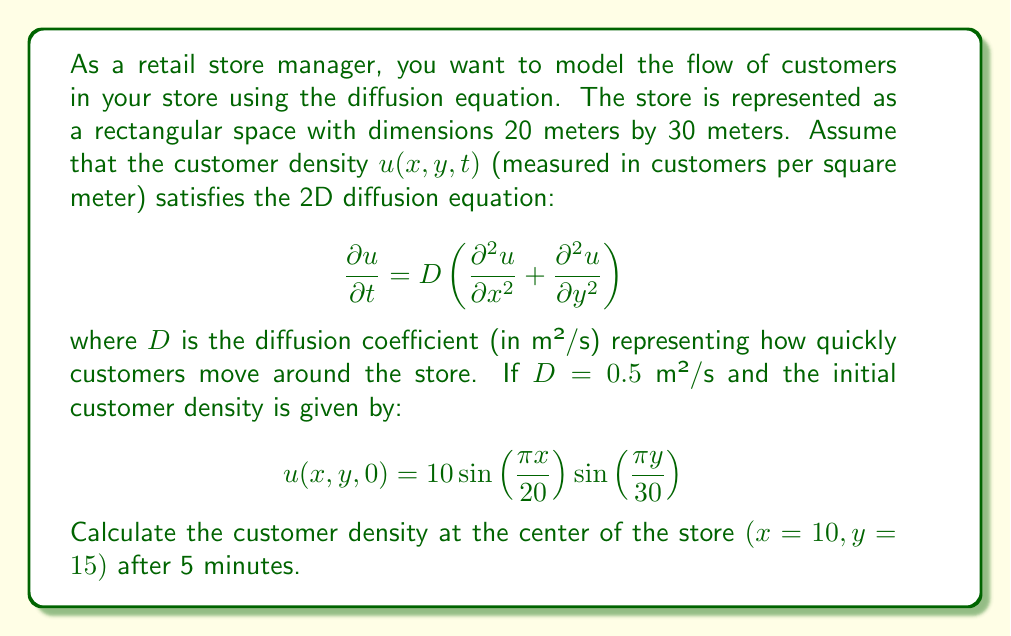Can you answer this question? To solve this problem, we'll follow these steps:

1) First, we need to recognize that the given initial condition satisfies the boundary conditions (zero density at the edges of the store) and has the form of a solution to the 2D diffusion equation.

2) The general solution to the 2D diffusion equation with these boundary conditions is:

   $$u(x,y,t) = A \sin\left(\frac{\pi x}{L_x}\right) \sin\left(\frac{\pi y}{L_y}\right) e^{-\lambda t}$$

   where $L_x = 20$ m and $L_y = 30$ m are the store dimensions.

3) Comparing this to our initial condition, we see that $A = 10$.

4) The decay constant $\lambda$ is given by:

   $$\lambda = D\pi^2 \left(\frac{1}{L_x^2} + \frac{1}{L_y^2}\right)$$

5) Substituting the values:

   $$\lambda = 0.5 \cdot \pi^2 \left(\frac{1}{20^2} + \frac{1}{30^2}\right) = 0.5 \cdot \pi^2 \cdot \frac{13}{3600} \approx 0.0178 \text{ s}^{-1}$$

6) Now we can write the full solution:

   $$u(x,y,t) = 10 \sin\left(\frac{\pi x}{20}\right) \sin\left(\frac{\pi y}{30}\right) e^{-0.0178t}$$

7) To find the density at the center after 5 minutes, we substitute $x=10$, $y=15$, and $t = 5 \cdot 60 = 300$ seconds:

   $$u(10,15,300) = 10 \sin\left(\frac{\pi \cdot 10}{20}\right) \sin\left(\frac{\pi \cdot 15}{30}\right) e^{-0.0178 \cdot 300}$$

8) Simplifying:

   $$u(10,15,300) = 10 \cdot 1 \cdot 1 \cdot e^{-5.34} \approx 0.48 \text{ customers/m²}$$
Answer: The customer density at the center of the store $(x=10, y=15)$ after 5 minutes is approximately 0.48 customers per square meter. 